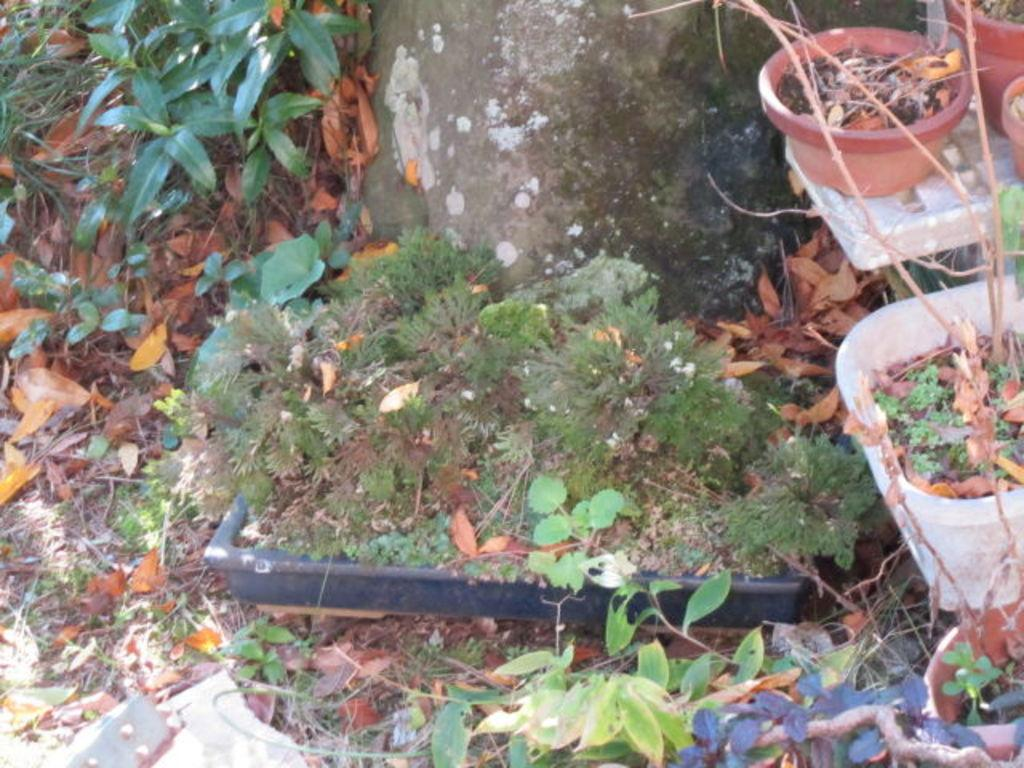What can be seen in the potted in the image? There are pots with plants in the image. What is present on the ground in the image? There are dried leaves on the ground. What else can be seen in the image besides the potted plants? There are other plants visible in the image. What architectural feature can be seen in the background of the image? There is a small wall in the background of the image. Where is the kitty sleeping in the image? There is no kitty present in the image. What type of rake is being used to clean the leaves in the image? There is no rake visible in the image; only dried leaves are present on the ground. 